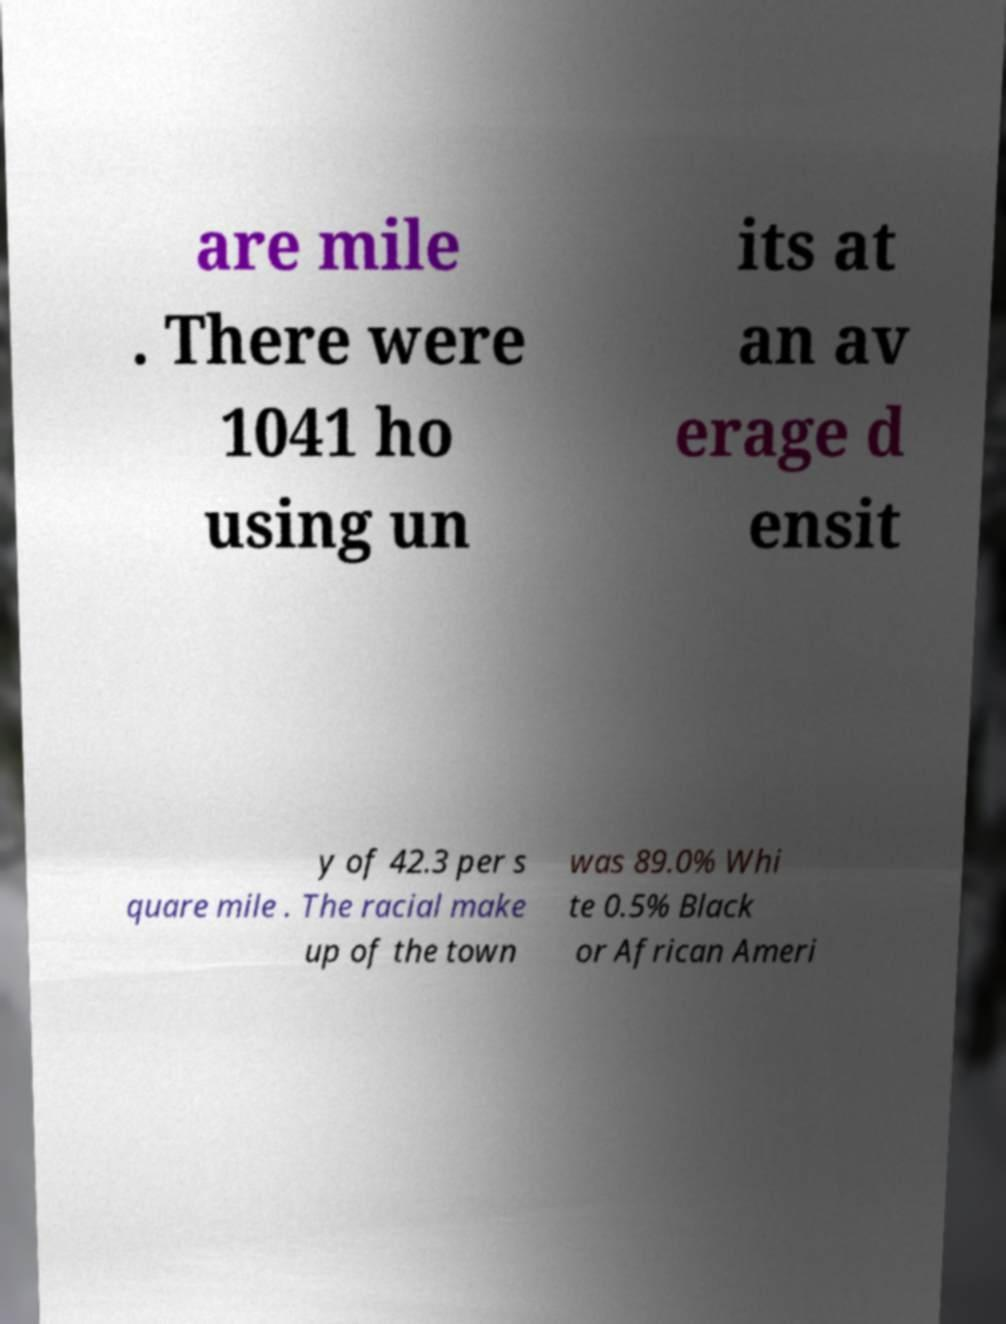For documentation purposes, I need the text within this image transcribed. Could you provide that? are mile . There were 1041 ho using un its at an av erage d ensit y of 42.3 per s quare mile . The racial make up of the town was 89.0% Whi te 0.5% Black or African Ameri 